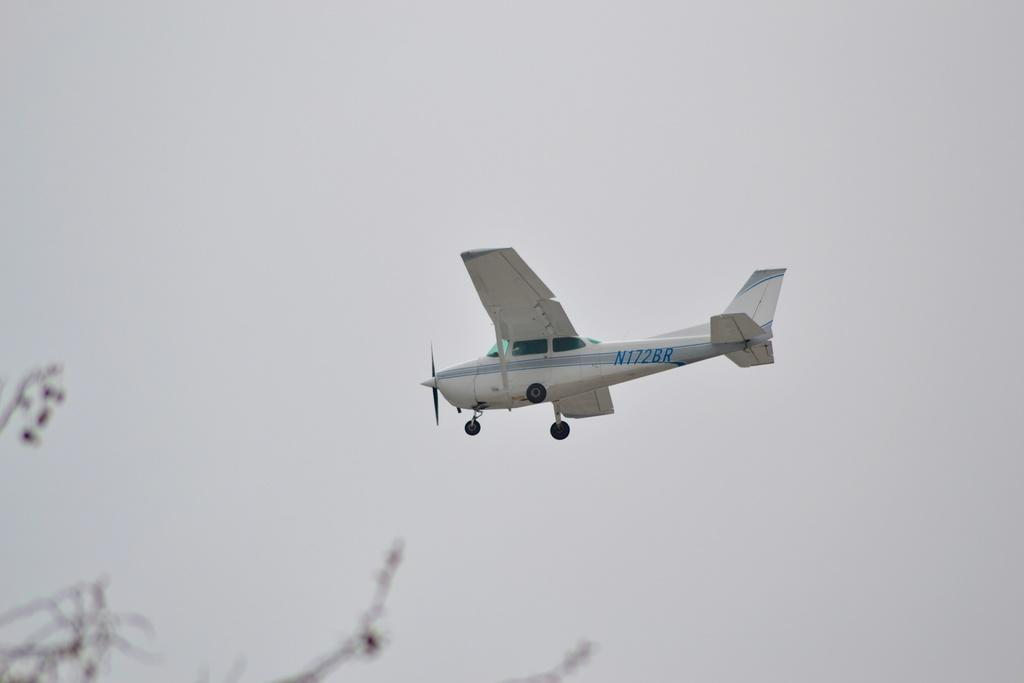What is the main subject of the image? The main subject of the image is a jet plane. What is the jet plane doing in the image? The jet plane is flying in the air. What is the color of the jet plane? The jet plane is white in color. What can be seen in the background of the image? There is sky visible in the background of the image. What type of vegetation is visible at the bottom of the image? The stems of a plant are visible at the bottom of the image. What type of skin condition can be seen on the jet plane in the image? There is no skin condition present on the jet plane in the image, as it is an inanimate object made of metal and other materials. 